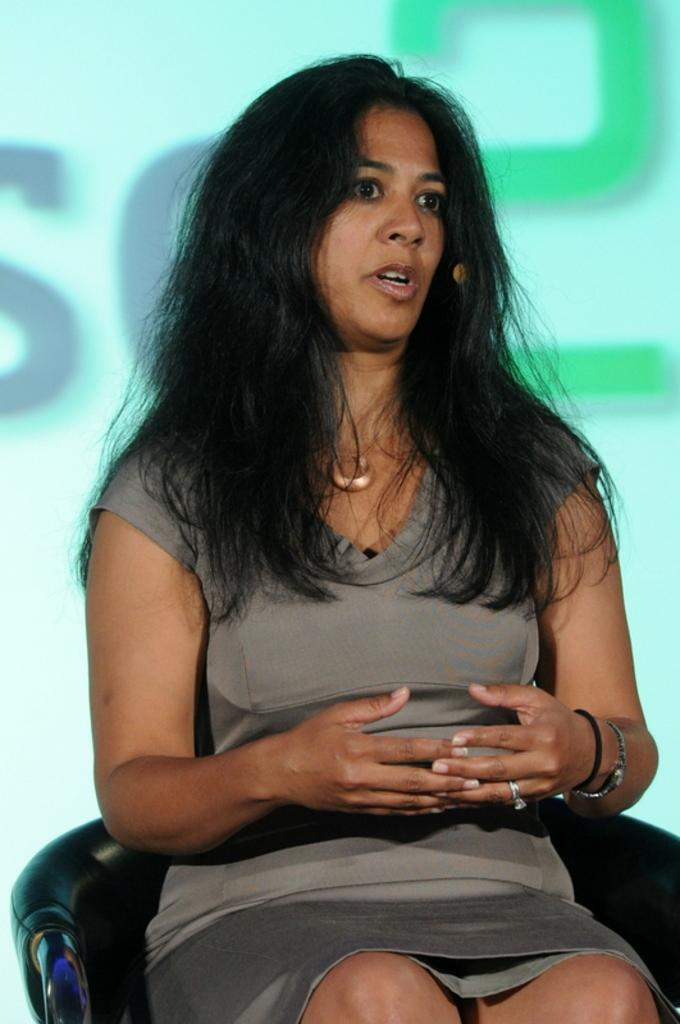Who is the main subject in the image? There is a girl in the image. What is the girl doing in the image? The girl is sitting on a chair. What can be seen behind the girl? There is text visible on a screen behind the girl. What type of liquid is the girl testing in the image? There is no liquid or testing activity present in the image; it only shows a girl sitting on a chair with a screen behind her. 